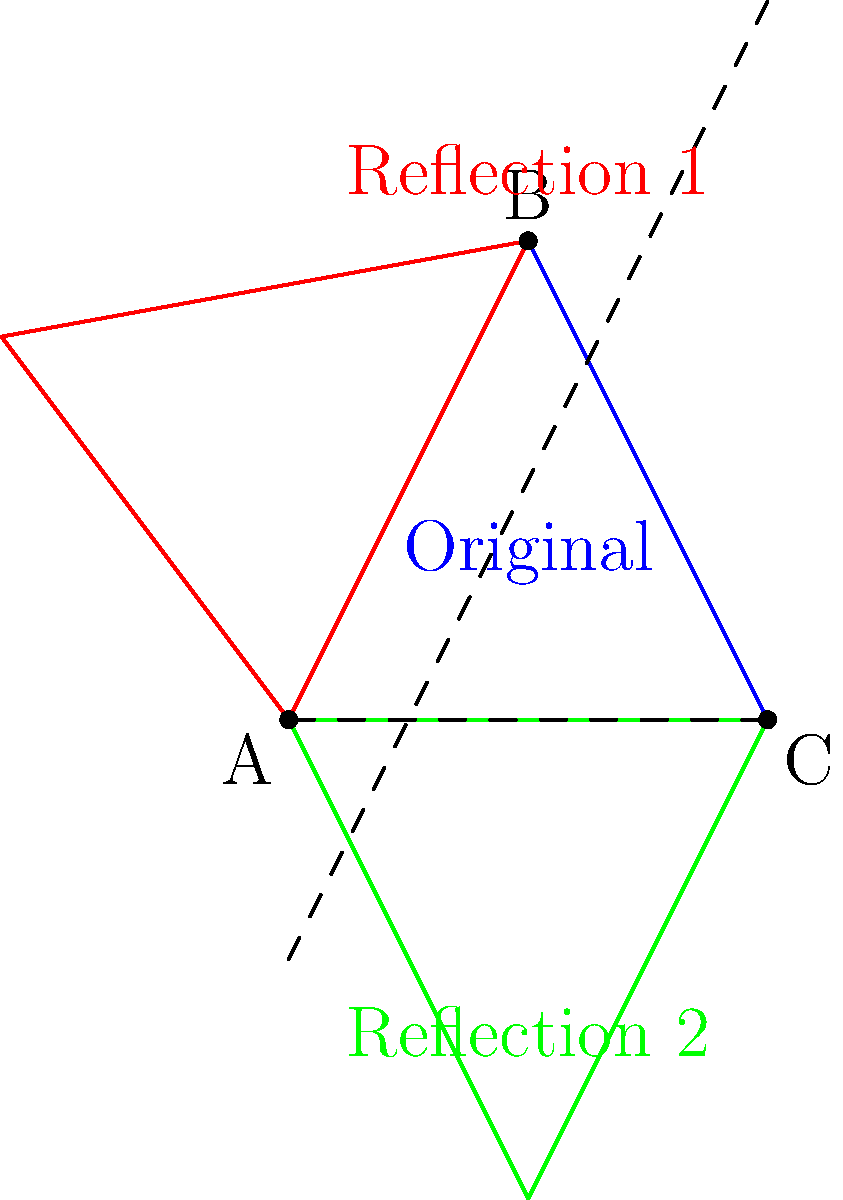In the context of creating a visual representation of SCP-173, you're tasked with reflecting its silhouette across multiple axes. Given the original blue triangle ABC representing SCP-173's silhouette, how many unique shapes (including the original) are formed after reflecting it across the x-axis and the line $y=x$? Let's approach this step-by-step:

1) We start with the original blue triangle ABC, representing SCP-173's silhouette.

2) First reflection:
   - The triangle is reflected across the x-axis (the dashed horizontal line).
   - This creates the green triangle, which is distinct from the original.

3) Second reflection:
   - The original triangle is reflected across the line $y=x$ (the dashed diagonal line).
   - This creates the red triangle, which is also distinct from both the original and the first reflection.

4) Counting unique shapes:
   - The original blue triangle
   - The green triangle (reflection across x-axis)
   - The red triangle (reflection across $y=x$)

5) Note that further reflections of these reflections would not create any new unique shapes, as they would overlap with existing ones.

Therefore, we have 3 unique shapes in total: the original and its two reflections.
Answer: 3 